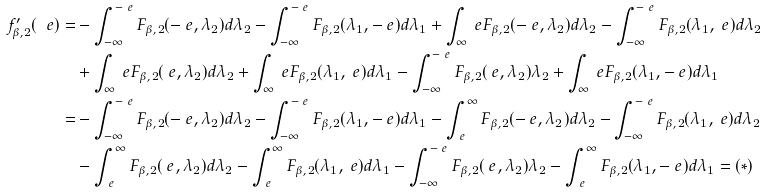Convert formula to latex. <formula><loc_0><loc_0><loc_500><loc_500>f ^ { \prime } _ { \beta , 2 } ( \ e ) = & - \int _ { - \infty } ^ { - \ e } F _ { \beta , 2 } ( - \ e , \lambda _ { 2 } ) d \lambda _ { 2 } - \int _ { - \infty } ^ { - \ e } F _ { \beta , 2 } ( \lambda _ { 1 } , - \ e ) d \lambda _ { 1 } + \int _ { \infty } ^ { \ } e F _ { \beta , 2 } ( - \ e , \lambda _ { 2 } ) d \lambda _ { 2 } - \int _ { - \infty } ^ { - \ e } F _ { \beta , 2 } ( \lambda _ { 1 } , \ e ) d \lambda _ { 2 } \\ & + \int _ { \infty } ^ { \ } e F _ { \beta , 2 } ( \ e , \lambda _ { 2 } ) d \lambda _ { 2 } + \int _ { \infty } ^ { \ } e F _ { \beta , 2 } ( \lambda _ { 1 } , \ e ) d \lambda _ { 1 } - \int _ { - \infty } ^ { - \ e } F _ { \beta , 2 } ( \ e , \lambda _ { 2 } ) \lambda _ { 2 } + \int _ { \infty } ^ { \ } e F _ { \beta , 2 } ( \lambda _ { 1 } , - \ e ) d \lambda _ { 1 } \\ = & - \int _ { - \infty } ^ { - \ e } F _ { \beta , 2 } ( - \ e , \lambda _ { 2 } ) d \lambda _ { 2 } - \int _ { - \infty } ^ { - \ e } F _ { \beta , 2 } ( \lambda _ { 1 } , - \ e ) d \lambda _ { 1 } - \int _ { \ e } ^ { \infty } F _ { \beta , 2 } ( - \ e , \lambda _ { 2 } ) d \lambda _ { 2 } - \int _ { - \infty } ^ { - \ e } F _ { \beta , 2 } ( \lambda _ { 1 } , \ e ) d \lambda _ { 2 } \\ & - \int _ { \ e } ^ { \infty } F _ { \beta , 2 } ( \ e , \lambda _ { 2 } ) d \lambda _ { 2 } - \int _ { \ e } ^ { \infty } F _ { \beta , 2 } ( \lambda _ { 1 } , \ e ) d \lambda _ { 1 } - \int _ { - \infty } ^ { - \ e } F _ { \beta , 2 } ( \ e , \lambda _ { 2 } ) \lambda _ { 2 } - \int _ { \ e } ^ { \infty } F _ { \beta , 2 } ( \lambda _ { 1 } , - \ e ) d \lambda _ { 1 } = ( * )</formula> 